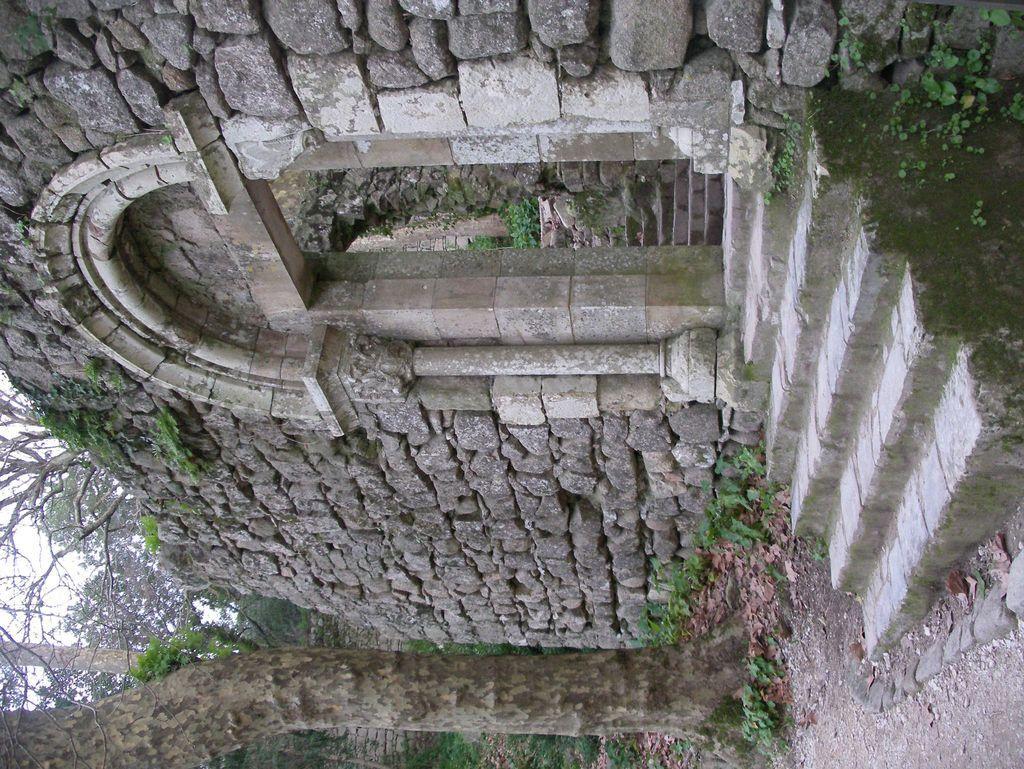Can you describe this image briefly? It is a tilted image,it looks like some monument made up of rocks and in front of the rock wall there is a tree trunk. 